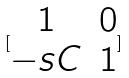Convert formula to latex. <formula><loc_0><loc_0><loc_500><loc_500>[ \begin{matrix} 1 & 0 \\ - s C & 1 \end{matrix} ]</formula> 